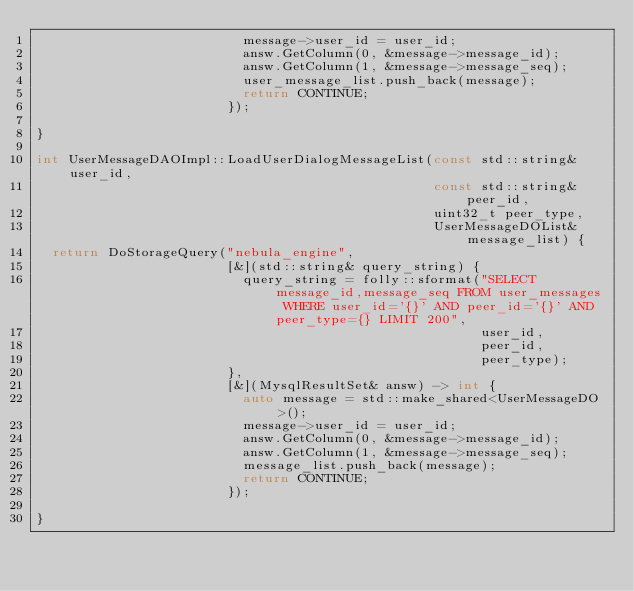<code> <loc_0><loc_0><loc_500><loc_500><_C++_>                          message->user_id = user_id;
                          answ.GetColumn(0, &message->message_id);
                          answ.GetColumn(1, &message->message_seq);
                          user_message_list.push_back(message);
                          return CONTINUE;
                        });

}

int UserMessageDAOImpl::LoadUserDialogMessageList(const std::string& user_id,
                                                  const std::string& peer_id,
                                                  uint32_t peer_type,
                                                  UserMessageDOList& message_list) {
  return DoStorageQuery("nebula_engine",
                        [&](std::string& query_string) {
                          query_string = folly::sformat("SELECT message_id,message_seq FROM user_messages WHERE user_id='{}' AND peer_id='{}' AND peer_type={} LIMIT 200",
                                                        user_id,
                                                        peer_id,
                                                        peer_type);
                        },
                        [&](MysqlResultSet& answ) -> int {
                          auto message = std::make_shared<UserMessageDO>();
                          message->user_id = user_id;
                          answ.GetColumn(0, &message->message_id);
                          answ.GetColumn(1, &message->message_seq);
                          message_list.push_back(message);
                          return CONTINUE;
                        });

}
</code> 